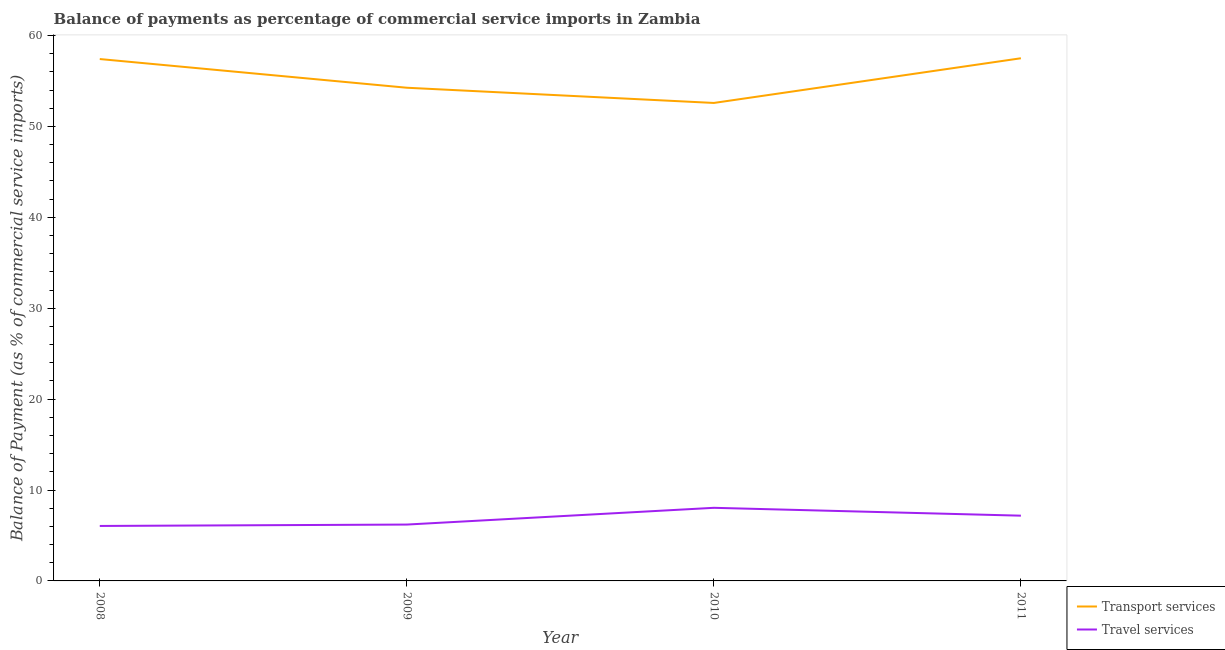How many different coloured lines are there?
Ensure brevity in your answer.  2. What is the balance of payments of transport services in 2009?
Offer a very short reply. 54.26. Across all years, what is the maximum balance of payments of travel services?
Offer a very short reply. 8.04. Across all years, what is the minimum balance of payments of travel services?
Make the answer very short. 6.05. In which year was the balance of payments of travel services maximum?
Your answer should be compact. 2010. In which year was the balance of payments of travel services minimum?
Make the answer very short. 2008. What is the total balance of payments of travel services in the graph?
Ensure brevity in your answer.  27.47. What is the difference between the balance of payments of transport services in 2008 and that in 2009?
Provide a succinct answer. 3.16. What is the difference between the balance of payments of transport services in 2010 and the balance of payments of travel services in 2011?
Your answer should be compact. 45.41. What is the average balance of payments of travel services per year?
Provide a short and direct response. 6.87. In the year 2009, what is the difference between the balance of payments of travel services and balance of payments of transport services?
Give a very brief answer. -48.06. In how many years, is the balance of payments of travel services greater than 58 %?
Make the answer very short. 0. What is the ratio of the balance of payments of travel services in 2008 to that in 2011?
Give a very brief answer. 0.84. Is the balance of payments of travel services in 2008 less than that in 2010?
Your answer should be very brief. Yes. Is the difference between the balance of payments of travel services in 2008 and 2010 greater than the difference between the balance of payments of transport services in 2008 and 2010?
Ensure brevity in your answer.  No. What is the difference between the highest and the second highest balance of payments of travel services?
Your answer should be compact. 0.87. What is the difference between the highest and the lowest balance of payments of transport services?
Make the answer very short. 4.92. In how many years, is the balance of payments of travel services greater than the average balance of payments of travel services taken over all years?
Your answer should be very brief. 2. Is the sum of the balance of payments of travel services in 2008 and 2011 greater than the maximum balance of payments of transport services across all years?
Provide a short and direct response. No. Is the balance of payments of transport services strictly greater than the balance of payments of travel services over the years?
Your answer should be very brief. Yes. Is the balance of payments of travel services strictly less than the balance of payments of transport services over the years?
Keep it short and to the point. Yes. How many lines are there?
Give a very brief answer. 2. Are the values on the major ticks of Y-axis written in scientific E-notation?
Give a very brief answer. No. Does the graph contain any zero values?
Your answer should be compact. No. How are the legend labels stacked?
Give a very brief answer. Vertical. What is the title of the graph?
Keep it short and to the point. Balance of payments as percentage of commercial service imports in Zambia. What is the label or title of the X-axis?
Your answer should be very brief. Year. What is the label or title of the Y-axis?
Give a very brief answer. Balance of Payment (as % of commercial service imports). What is the Balance of Payment (as % of commercial service imports) of Transport services in 2008?
Your response must be concise. 57.42. What is the Balance of Payment (as % of commercial service imports) of Travel services in 2008?
Keep it short and to the point. 6.05. What is the Balance of Payment (as % of commercial service imports) in Transport services in 2009?
Your answer should be very brief. 54.26. What is the Balance of Payment (as % of commercial service imports) of Travel services in 2009?
Offer a terse response. 6.2. What is the Balance of Payment (as % of commercial service imports) of Transport services in 2010?
Your response must be concise. 52.59. What is the Balance of Payment (as % of commercial service imports) of Travel services in 2010?
Your answer should be very brief. 8.04. What is the Balance of Payment (as % of commercial service imports) in Transport services in 2011?
Offer a terse response. 57.5. What is the Balance of Payment (as % of commercial service imports) in Travel services in 2011?
Your answer should be compact. 7.18. Across all years, what is the maximum Balance of Payment (as % of commercial service imports) of Transport services?
Your answer should be compact. 57.5. Across all years, what is the maximum Balance of Payment (as % of commercial service imports) of Travel services?
Your response must be concise. 8.04. Across all years, what is the minimum Balance of Payment (as % of commercial service imports) of Transport services?
Your answer should be very brief. 52.59. Across all years, what is the minimum Balance of Payment (as % of commercial service imports) of Travel services?
Offer a terse response. 6.05. What is the total Balance of Payment (as % of commercial service imports) of Transport services in the graph?
Ensure brevity in your answer.  221.77. What is the total Balance of Payment (as % of commercial service imports) in Travel services in the graph?
Make the answer very short. 27.47. What is the difference between the Balance of Payment (as % of commercial service imports) of Transport services in 2008 and that in 2009?
Ensure brevity in your answer.  3.16. What is the difference between the Balance of Payment (as % of commercial service imports) in Travel services in 2008 and that in 2009?
Ensure brevity in your answer.  -0.15. What is the difference between the Balance of Payment (as % of commercial service imports) of Transport services in 2008 and that in 2010?
Your response must be concise. 4.83. What is the difference between the Balance of Payment (as % of commercial service imports) in Travel services in 2008 and that in 2010?
Keep it short and to the point. -2. What is the difference between the Balance of Payment (as % of commercial service imports) in Transport services in 2008 and that in 2011?
Offer a very short reply. -0.09. What is the difference between the Balance of Payment (as % of commercial service imports) of Travel services in 2008 and that in 2011?
Offer a very short reply. -1.13. What is the difference between the Balance of Payment (as % of commercial service imports) of Transport services in 2009 and that in 2010?
Your response must be concise. 1.67. What is the difference between the Balance of Payment (as % of commercial service imports) in Travel services in 2009 and that in 2010?
Your answer should be very brief. -1.84. What is the difference between the Balance of Payment (as % of commercial service imports) of Transport services in 2009 and that in 2011?
Keep it short and to the point. -3.24. What is the difference between the Balance of Payment (as % of commercial service imports) in Travel services in 2009 and that in 2011?
Your answer should be compact. -0.98. What is the difference between the Balance of Payment (as % of commercial service imports) in Transport services in 2010 and that in 2011?
Give a very brief answer. -4.92. What is the difference between the Balance of Payment (as % of commercial service imports) in Travel services in 2010 and that in 2011?
Ensure brevity in your answer.  0.87. What is the difference between the Balance of Payment (as % of commercial service imports) in Transport services in 2008 and the Balance of Payment (as % of commercial service imports) in Travel services in 2009?
Your answer should be compact. 51.22. What is the difference between the Balance of Payment (as % of commercial service imports) of Transport services in 2008 and the Balance of Payment (as % of commercial service imports) of Travel services in 2010?
Ensure brevity in your answer.  49.37. What is the difference between the Balance of Payment (as % of commercial service imports) of Transport services in 2008 and the Balance of Payment (as % of commercial service imports) of Travel services in 2011?
Offer a terse response. 50.24. What is the difference between the Balance of Payment (as % of commercial service imports) in Transport services in 2009 and the Balance of Payment (as % of commercial service imports) in Travel services in 2010?
Ensure brevity in your answer.  46.22. What is the difference between the Balance of Payment (as % of commercial service imports) in Transport services in 2009 and the Balance of Payment (as % of commercial service imports) in Travel services in 2011?
Provide a short and direct response. 47.08. What is the difference between the Balance of Payment (as % of commercial service imports) of Transport services in 2010 and the Balance of Payment (as % of commercial service imports) of Travel services in 2011?
Offer a terse response. 45.41. What is the average Balance of Payment (as % of commercial service imports) of Transport services per year?
Your answer should be compact. 55.44. What is the average Balance of Payment (as % of commercial service imports) of Travel services per year?
Offer a very short reply. 6.87. In the year 2008, what is the difference between the Balance of Payment (as % of commercial service imports) of Transport services and Balance of Payment (as % of commercial service imports) of Travel services?
Provide a succinct answer. 51.37. In the year 2009, what is the difference between the Balance of Payment (as % of commercial service imports) in Transport services and Balance of Payment (as % of commercial service imports) in Travel services?
Your answer should be very brief. 48.06. In the year 2010, what is the difference between the Balance of Payment (as % of commercial service imports) in Transport services and Balance of Payment (as % of commercial service imports) in Travel services?
Offer a terse response. 44.54. In the year 2011, what is the difference between the Balance of Payment (as % of commercial service imports) in Transport services and Balance of Payment (as % of commercial service imports) in Travel services?
Offer a terse response. 50.32. What is the ratio of the Balance of Payment (as % of commercial service imports) in Transport services in 2008 to that in 2009?
Your answer should be very brief. 1.06. What is the ratio of the Balance of Payment (as % of commercial service imports) in Travel services in 2008 to that in 2009?
Provide a succinct answer. 0.98. What is the ratio of the Balance of Payment (as % of commercial service imports) in Transport services in 2008 to that in 2010?
Your response must be concise. 1.09. What is the ratio of the Balance of Payment (as % of commercial service imports) in Travel services in 2008 to that in 2010?
Provide a succinct answer. 0.75. What is the ratio of the Balance of Payment (as % of commercial service imports) of Transport services in 2008 to that in 2011?
Provide a short and direct response. 1. What is the ratio of the Balance of Payment (as % of commercial service imports) of Travel services in 2008 to that in 2011?
Make the answer very short. 0.84. What is the ratio of the Balance of Payment (as % of commercial service imports) in Transport services in 2009 to that in 2010?
Offer a very short reply. 1.03. What is the ratio of the Balance of Payment (as % of commercial service imports) in Travel services in 2009 to that in 2010?
Provide a succinct answer. 0.77. What is the ratio of the Balance of Payment (as % of commercial service imports) of Transport services in 2009 to that in 2011?
Give a very brief answer. 0.94. What is the ratio of the Balance of Payment (as % of commercial service imports) in Travel services in 2009 to that in 2011?
Keep it short and to the point. 0.86. What is the ratio of the Balance of Payment (as % of commercial service imports) in Transport services in 2010 to that in 2011?
Provide a short and direct response. 0.91. What is the ratio of the Balance of Payment (as % of commercial service imports) in Travel services in 2010 to that in 2011?
Your answer should be compact. 1.12. What is the difference between the highest and the second highest Balance of Payment (as % of commercial service imports) in Transport services?
Provide a succinct answer. 0.09. What is the difference between the highest and the second highest Balance of Payment (as % of commercial service imports) in Travel services?
Your answer should be very brief. 0.87. What is the difference between the highest and the lowest Balance of Payment (as % of commercial service imports) of Transport services?
Your answer should be compact. 4.92. What is the difference between the highest and the lowest Balance of Payment (as % of commercial service imports) in Travel services?
Give a very brief answer. 2. 